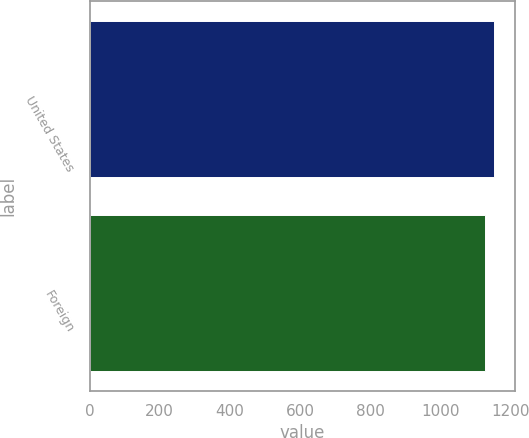<chart> <loc_0><loc_0><loc_500><loc_500><bar_chart><fcel>United States<fcel>Foreign<nl><fcel>1155<fcel>1129<nl></chart> 